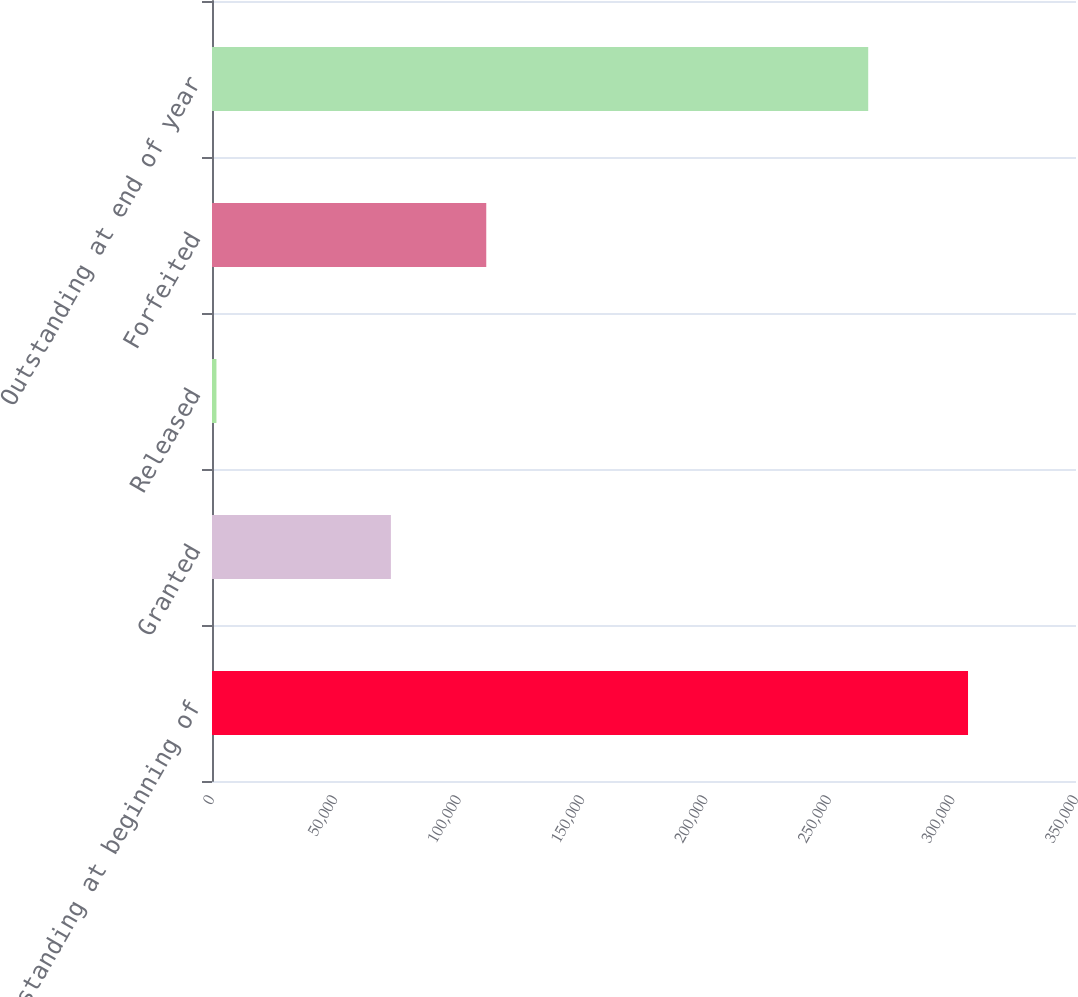Convert chart. <chart><loc_0><loc_0><loc_500><loc_500><bar_chart><fcel>Outstanding at beginning of<fcel>Granted<fcel>Released<fcel>Forfeited<fcel>Outstanding at end of year<nl><fcel>306261<fcel>72470<fcel>1802<fcel>111100<fcel>265829<nl></chart> 